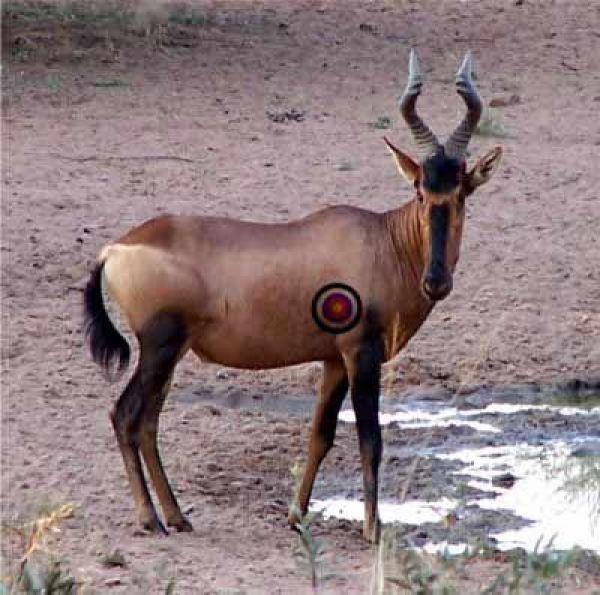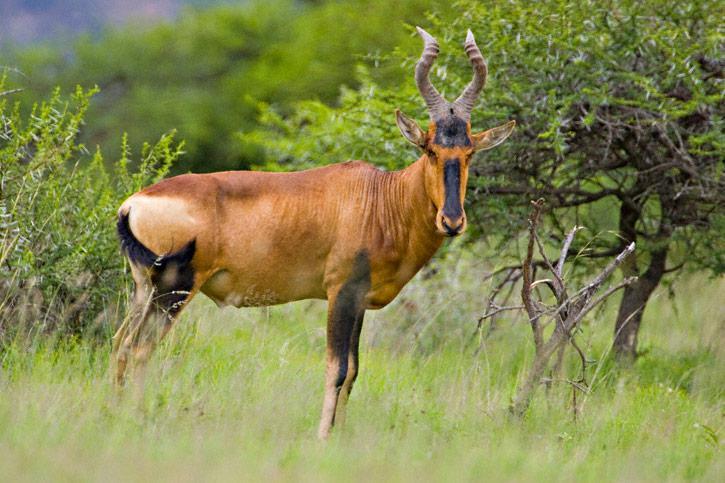The first image is the image on the left, the second image is the image on the right. For the images displayed, is the sentence "In one of the images there is a person posing behind an antelope." factually correct? Answer yes or no. No. The first image is the image on the left, the second image is the image on the right. Assess this claim about the two images: "A hunter with a gun poses behind a downed horned animal in one image.". Correct or not? Answer yes or no. No. 